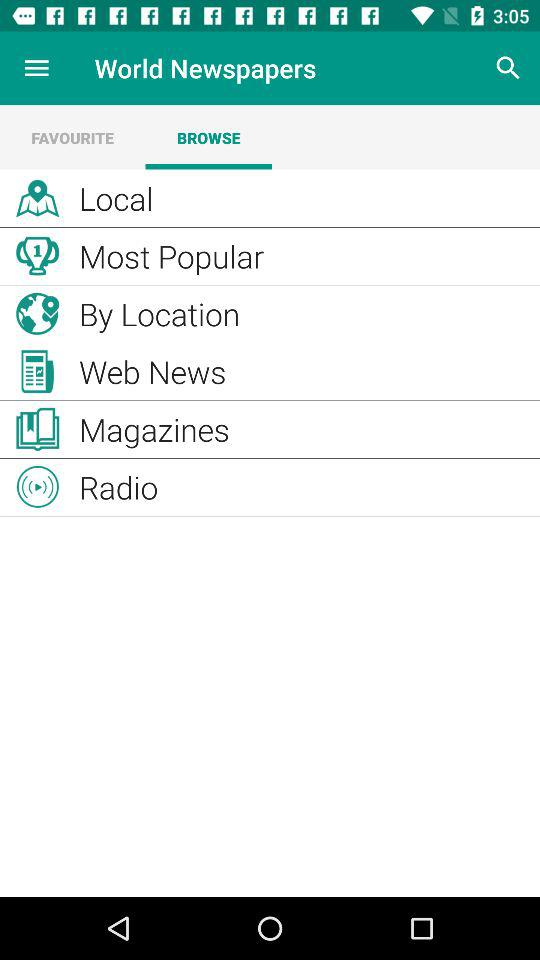Which radio stations are available?
When the provided information is insufficient, respond with <no answer>. <no answer> 